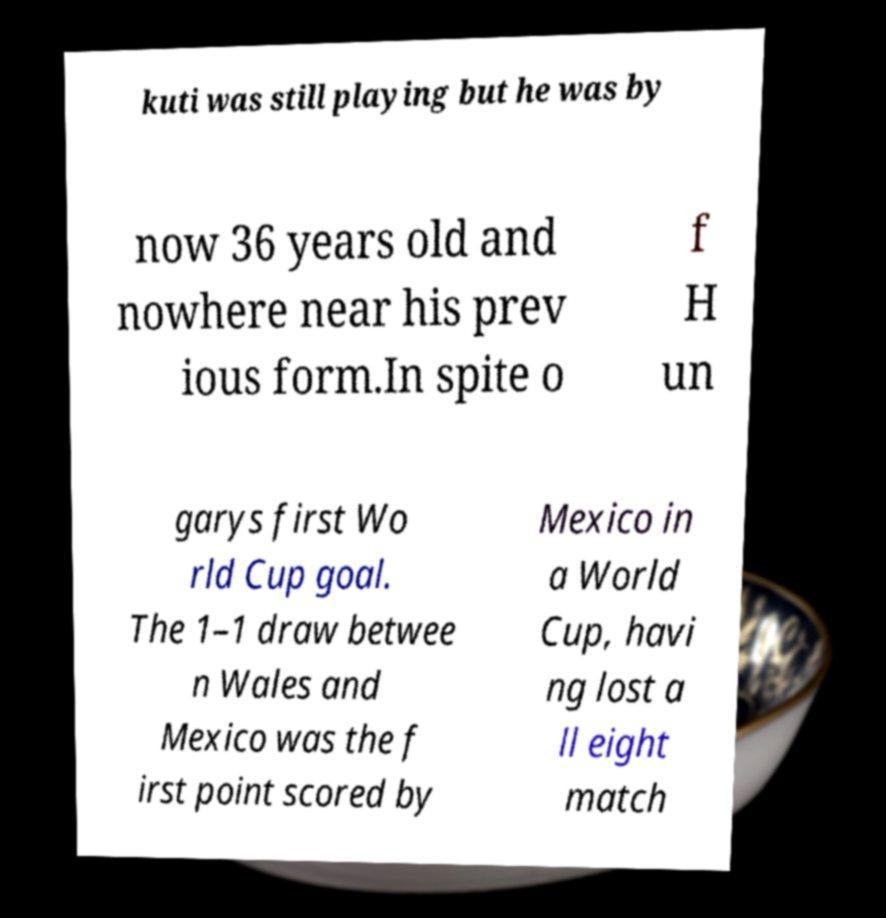Please read and relay the text visible in this image. What does it say? kuti was still playing but he was by now 36 years old and nowhere near his prev ious form.In spite o f H un garys first Wo rld Cup goal. The 1–1 draw betwee n Wales and Mexico was the f irst point scored by Mexico in a World Cup, havi ng lost a ll eight match 